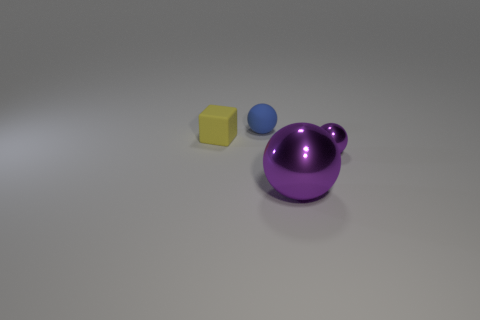Is there another rubber object that has the same shape as the small yellow thing?
Your answer should be very brief. No. What is the shape of the yellow object?
Give a very brief answer. Cube. Is the big purple object the same shape as the tiny blue thing?
Your response must be concise. Yes. Are there any other things that have the same color as the large metal object?
Offer a terse response. Yes. There is a rubber thing that is the same shape as the tiny purple shiny object; what is its color?
Keep it short and to the point. Blue. Are there more tiny blue spheres that are in front of the large purple ball than blue spheres?
Keep it short and to the point. No. What color is the small sphere that is behind the cube?
Provide a succinct answer. Blue. Do the yellow rubber object and the blue matte sphere have the same size?
Your response must be concise. Yes. The yellow object is what size?
Your answer should be compact. Small. What is the shape of the other thing that is the same color as the large thing?
Offer a very short reply. Sphere. 